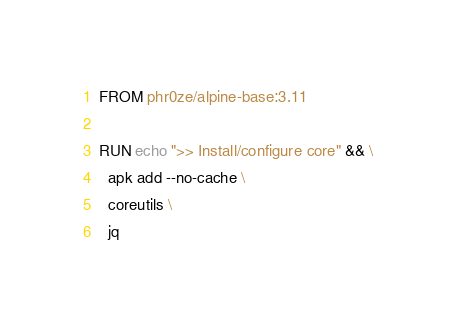<code> <loc_0><loc_0><loc_500><loc_500><_Dockerfile_>FROM phr0ze/alpine-base:3.11

RUN echo ">> Install/configure core" && \
  apk add --no-cache \
  coreutils \
  jq
</code> 